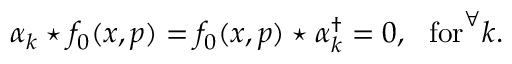Convert formula to latex. <formula><loc_0><loc_0><loc_500><loc_500>\alpha _ { k } ^ { * } f _ { 0 } ( x , p ) = f _ { 0 } ( x , p ) ^ { * } \alpha _ { k } ^ { \dagger } = 0 , f o r ^ { \forall } k .</formula> 